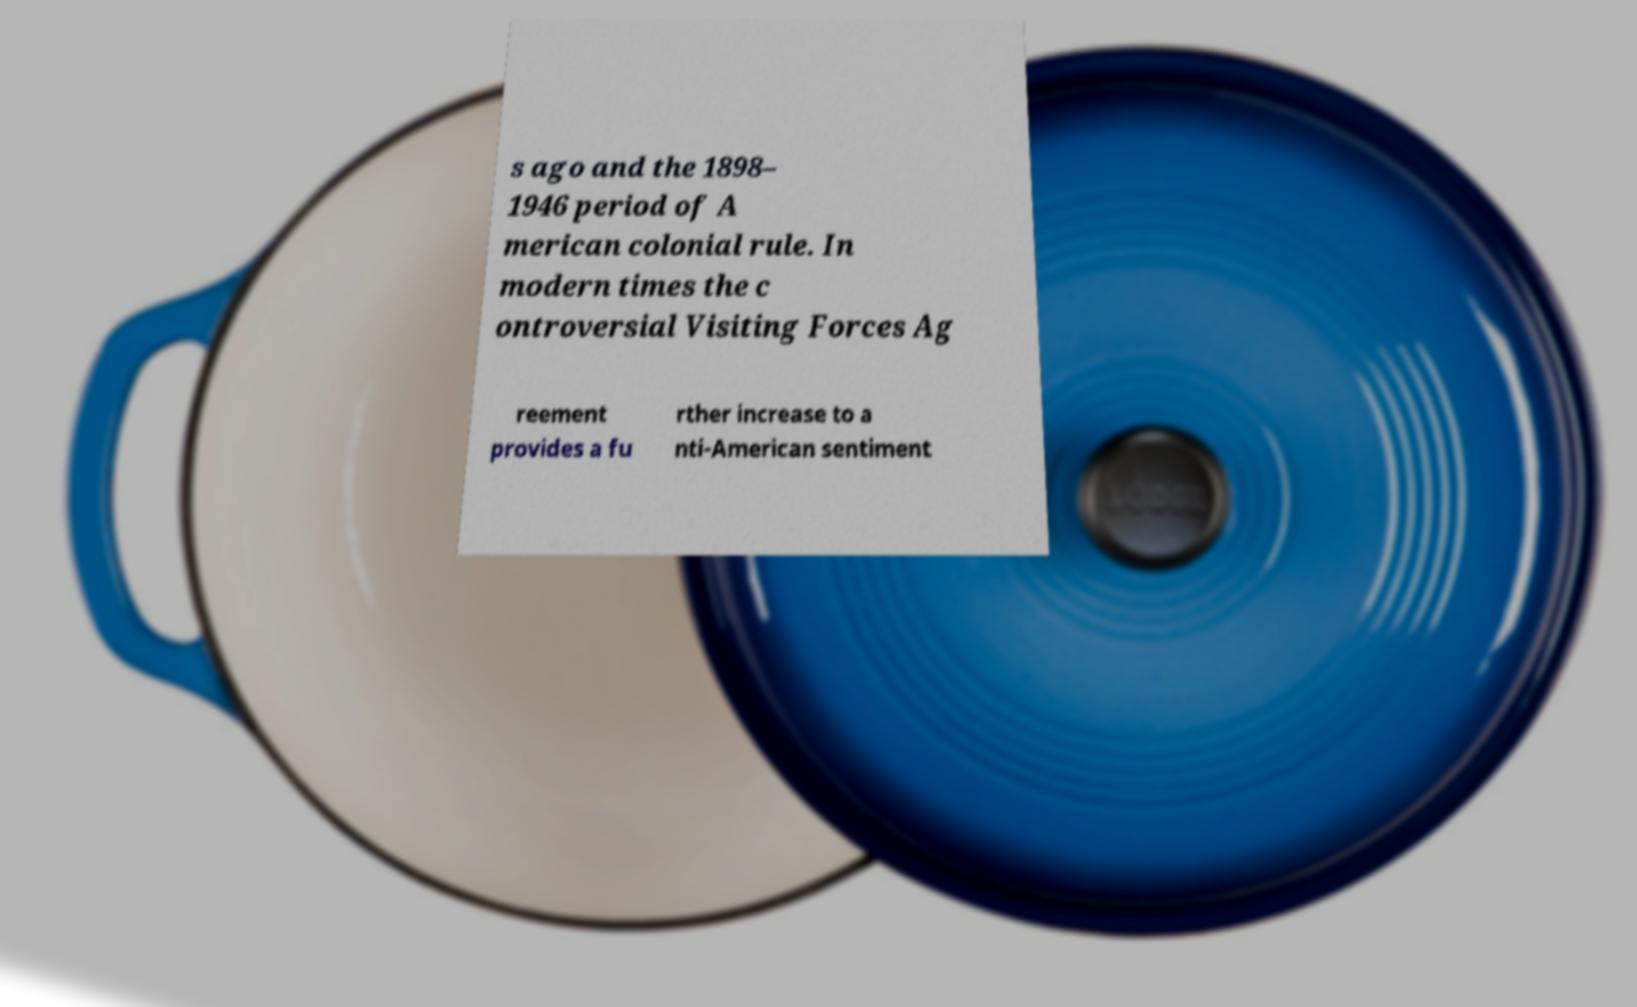Could you extract and type out the text from this image? s ago and the 1898– 1946 period of A merican colonial rule. In modern times the c ontroversial Visiting Forces Ag reement provides a fu rther increase to a nti-American sentiment 